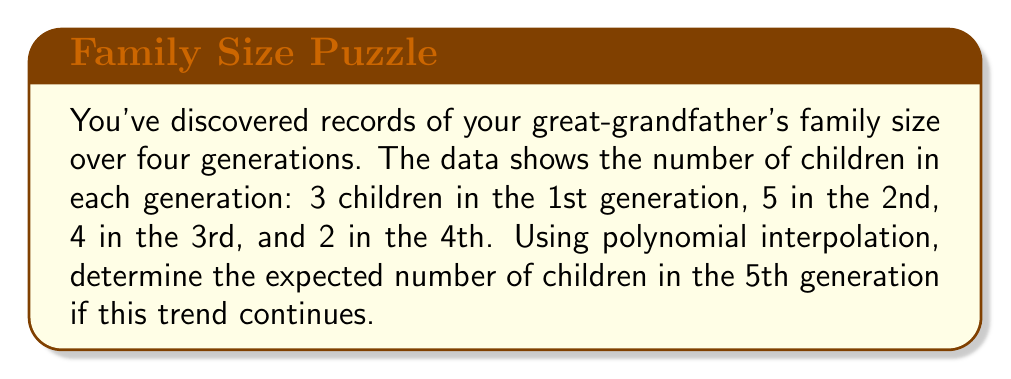Solve this math problem. To solve this problem, we'll use Lagrange polynomial interpolation:

1) Let's define our data points:
   $(x_1, y_1) = (1, 3)$, $(x_2, y_2) = (2, 5)$, $(x_3, y_3) = (3, 4)$, $(x_4, y_4) = (4, 2)$

2) The Lagrange interpolation polynomial is:

   $$L(x) = \sum_{i=1}^n y_i \prod_{j \neq i} \frac{x - x_j}{x_i - x_j}$$

3) Expanding this for our 4 points:

   $$L(x) = 3\frac{(x-2)(x-3)(x-4)}{(1-2)(1-3)(1-4)} + 5\frac{(x-1)(x-3)(x-4)}{(2-1)(2-3)(2-4)} + 4\frac{(x-1)(x-2)(x-4)}{(3-1)(3-2)(3-4)} + 2\frac{(x-1)(x-2)(x-3)}{(4-1)(4-2)(4-3)}$$

4) Simplify:

   $$L(x) = 3\frac{(x-2)(x-3)(x-4)}{(-1)(-2)(-3)} + 5\frac{(x-1)(x-3)(x-4)}{(1)(-1)(-2)} + 4\frac{(x-1)(x-2)(x-4)}{(2)(1)(-1)} + 2\frac{(x-1)(x-2)(x-3)}{(3)(2)(1)}$$

5) Further simplification:

   $$L(x) = -\frac{1}{2}(x-2)(x-3)(x-4) + \frac{5}{2}(x-1)(x-3)(x-4) - 2(x-1)(x-2)(x-4) + \frac{1}{3}(x-1)(x-2)(x-3)$$

6) To find the expected number of children in the 5th generation, we need to calculate $L(5)$:

   $$L(5) = -\frac{1}{2}(3)(2)(1) + \frac{5}{2}(4)(2)(1) - 2(4)(3)(1) + \frac{1}{3}(4)(3)(2) = -3 + 20 - 24 + 8 = 1$$
Answer: 1 child 